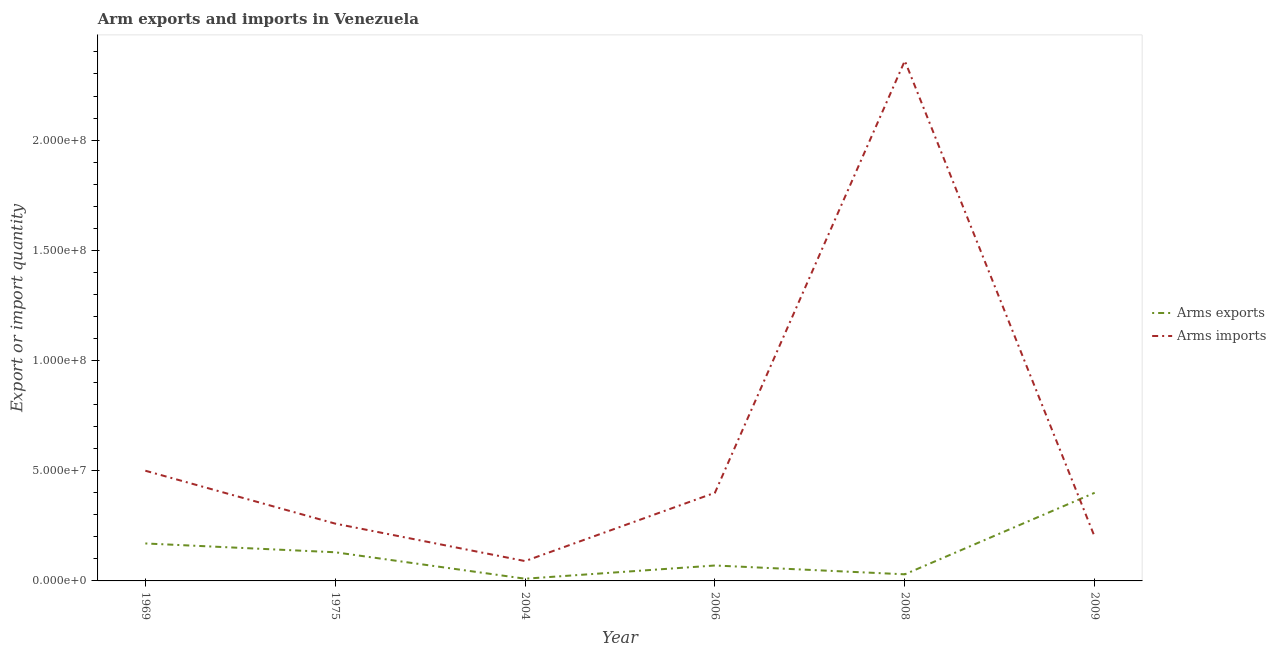Is the number of lines equal to the number of legend labels?
Your response must be concise. Yes. What is the arms imports in 2004?
Give a very brief answer. 9.00e+06. Across all years, what is the maximum arms imports?
Provide a succinct answer. 2.36e+08. Across all years, what is the minimum arms imports?
Provide a succinct answer. 9.00e+06. In which year was the arms imports minimum?
Provide a succinct answer. 2004. What is the total arms exports in the graph?
Provide a succinct answer. 8.10e+07. What is the difference between the arms exports in 1969 and that in 2006?
Provide a short and direct response. 1.00e+07. What is the difference between the arms imports in 1975 and the arms exports in 2009?
Offer a terse response. -1.40e+07. What is the average arms imports per year?
Provide a short and direct response. 6.35e+07. In the year 1969, what is the difference between the arms exports and arms imports?
Your answer should be very brief. -3.30e+07. In how many years, is the arms imports greater than 190000000?
Make the answer very short. 1. What is the ratio of the arms exports in 2004 to that in 2009?
Provide a short and direct response. 0.03. Is the difference between the arms imports in 2004 and 2009 greater than the difference between the arms exports in 2004 and 2009?
Your answer should be compact. Yes. What is the difference between the highest and the second highest arms imports?
Offer a very short reply. 1.86e+08. What is the difference between the highest and the lowest arms exports?
Your answer should be very brief. 3.90e+07. Does the arms exports monotonically increase over the years?
Your response must be concise. No. Is the arms imports strictly less than the arms exports over the years?
Keep it short and to the point. No. How many years are there in the graph?
Your response must be concise. 6. What is the difference between two consecutive major ticks on the Y-axis?
Give a very brief answer. 5.00e+07. Where does the legend appear in the graph?
Provide a succinct answer. Center right. How many legend labels are there?
Provide a short and direct response. 2. How are the legend labels stacked?
Ensure brevity in your answer.  Vertical. What is the title of the graph?
Offer a terse response. Arm exports and imports in Venezuela. Does "Primary completion rate" appear as one of the legend labels in the graph?
Your answer should be very brief. No. What is the label or title of the Y-axis?
Your response must be concise. Export or import quantity. What is the Export or import quantity in Arms exports in 1969?
Offer a terse response. 1.70e+07. What is the Export or import quantity of Arms exports in 1975?
Ensure brevity in your answer.  1.30e+07. What is the Export or import quantity in Arms imports in 1975?
Ensure brevity in your answer.  2.60e+07. What is the Export or import quantity in Arms exports in 2004?
Keep it short and to the point. 1.00e+06. What is the Export or import quantity in Arms imports in 2004?
Your answer should be very brief. 9.00e+06. What is the Export or import quantity of Arms imports in 2006?
Your answer should be very brief. 4.00e+07. What is the Export or import quantity in Arms imports in 2008?
Keep it short and to the point. 2.36e+08. What is the Export or import quantity of Arms exports in 2009?
Provide a short and direct response. 4.00e+07. What is the Export or import quantity in Arms imports in 2009?
Offer a very short reply. 2.00e+07. Across all years, what is the maximum Export or import quantity in Arms exports?
Make the answer very short. 4.00e+07. Across all years, what is the maximum Export or import quantity in Arms imports?
Your answer should be very brief. 2.36e+08. Across all years, what is the minimum Export or import quantity in Arms exports?
Provide a succinct answer. 1.00e+06. Across all years, what is the minimum Export or import quantity in Arms imports?
Ensure brevity in your answer.  9.00e+06. What is the total Export or import quantity in Arms exports in the graph?
Your answer should be very brief. 8.10e+07. What is the total Export or import quantity in Arms imports in the graph?
Offer a terse response. 3.81e+08. What is the difference between the Export or import quantity in Arms exports in 1969 and that in 1975?
Offer a very short reply. 4.00e+06. What is the difference between the Export or import quantity of Arms imports in 1969 and that in 1975?
Give a very brief answer. 2.40e+07. What is the difference between the Export or import quantity of Arms exports in 1969 and that in 2004?
Provide a succinct answer. 1.60e+07. What is the difference between the Export or import quantity of Arms imports in 1969 and that in 2004?
Ensure brevity in your answer.  4.10e+07. What is the difference between the Export or import quantity of Arms exports in 1969 and that in 2006?
Offer a very short reply. 1.00e+07. What is the difference between the Export or import quantity of Arms imports in 1969 and that in 2006?
Your answer should be compact. 1.00e+07. What is the difference between the Export or import quantity in Arms exports in 1969 and that in 2008?
Make the answer very short. 1.40e+07. What is the difference between the Export or import quantity of Arms imports in 1969 and that in 2008?
Offer a terse response. -1.86e+08. What is the difference between the Export or import quantity of Arms exports in 1969 and that in 2009?
Provide a succinct answer. -2.30e+07. What is the difference between the Export or import quantity of Arms imports in 1969 and that in 2009?
Your response must be concise. 3.00e+07. What is the difference between the Export or import quantity of Arms exports in 1975 and that in 2004?
Provide a short and direct response. 1.20e+07. What is the difference between the Export or import quantity in Arms imports in 1975 and that in 2004?
Provide a succinct answer. 1.70e+07. What is the difference between the Export or import quantity in Arms imports in 1975 and that in 2006?
Offer a terse response. -1.40e+07. What is the difference between the Export or import quantity in Arms imports in 1975 and that in 2008?
Your response must be concise. -2.10e+08. What is the difference between the Export or import quantity in Arms exports in 1975 and that in 2009?
Your answer should be compact. -2.70e+07. What is the difference between the Export or import quantity in Arms imports in 1975 and that in 2009?
Give a very brief answer. 6.00e+06. What is the difference between the Export or import quantity of Arms exports in 2004 and that in 2006?
Make the answer very short. -6.00e+06. What is the difference between the Export or import quantity of Arms imports in 2004 and that in 2006?
Your answer should be very brief. -3.10e+07. What is the difference between the Export or import quantity of Arms imports in 2004 and that in 2008?
Provide a succinct answer. -2.27e+08. What is the difference between the Export or import quantity of Arms exports in 2004 and that in 2009?
Offer a very short reply. -3.90e+07. What is the difference between the Export or import quantity of Arms imports in 2004 and that in 2009?
Offer a very short reply. -1.10e+07. What is the difference between the Export or import quantity in Arms imports in 2006 and that in 2008?
Offer a very short reply. -1.96e+08. What is the difference between the Export or import quantity in Arms exports in 2006 and that in 2009?
Ensure brevity in your answer.  -3.30e+07. What is the difference between the Export or import quantity of Arms exports in 2008 and that in 2009?
Ensure brevity in your answer.  -3.70e+07. What is the difference between the Export or import quantity of Arms imports in 2008 and that in 2009?
Offer a very short reply. 2.16e+08. What is the difference between the Export or import quantity of Arms exports in 1969 and the Export or import quantity of Arms imports in 1975?
Keep it short and to the point. -9.00e+06. What is the difference between the Export or import quantity in Arms exports in 1969 and the Export or import quantity in Arms imports in 2006?
Offer a very short reply. -2.30e+07. What is the difference between the Export or import quantity in Arms exports in 1969 and the Export or import quantity in Arms imports in 2008?
Provide a succinct answer. -2.19e+08. What is the difference between the Export or import quantity of Arms exports in 1975 and the Export or import quantity of Arms imports in 2004?
Your answer should be compact. 4.00e+06. What is the difference between the Export or import quantity in Arms exports in 1975 and the Export or import quantity in Arms imports in 2006?
Your answer should be very brief. -2.70e+07. What is the difference between the Export or import quantity in Arms exports in 1975 and the Export or import quantity in Arms imports in 2008?
Offer a terse response. -2.23e+08. What is the difference between the Export or import quantity of Arms exports in 1975 and the Export or import quantity of Arms imports in 2009?
Provide a short and direct response. -7.00e+06. What is the difference between the Export or import quantity of Arms exports in 2004 and the Export or import quantity of Arms imports in 2006?
Give a very brief answer. -3.90e+07. What is the difference between the Export or import quantity in Arms exports in 2004 and the Export or import quantity in Arms imports in 2008?
Offer a terse response. -2.35e+08. What is the difference between the Export or import quantity in Arms exports in 2004 and the Export or import quantity in Arms imports in 2009?
Offer a very short reply. -1.90e+07. What is the difference between the Export or import quantity in Arms exports in 2006 and the Export or import quantity in Arms imports in 2008?
Offer a very short reply. -2.29e+08. What is the difference between the Export or import quantity of Arms exports in 2006 and the Export or import quantity of Arms imports in 2009?
Provide a succinct answer. -1.30e+07. What is the difference between the Export or import quantity of Arms exports in 2008 and the Export or import quantity of Arms imports in 2009?
Ensure brevity in your answer.  -1.70e+07. What is the average Export or import quantity of Arms exports per year?
Make the answer very short. 1.35e+07. What is the average Export or import quantity in Arms imports per year?
Keep it short and to the point. 6.35e+07. In the year 1969, what is the difference between the Export or import quantity of Arms exports and Export or import quantity of Arms imports?
Offer a very short reply. -3.30e+07. In the year 1975, what is the difference between the Export or import quantity of Arms exports and Export or import quantity of Arms imports?
Keep it short and to the point. -1.30e+07. In the year 2004, what is the difference between the Export or import quantity in Arms exports and Export or import quantity in Arms imports?
Keep it short and to the point. -8.00e+06. In the year 2006, what is the difference between the Export or import quantity in Arms exports and Export or import quantity in Arms imports?
Keep it short and to the point. -3.30e+07. In the year 2008, what is the difference between the Export or import quantity in Arms exports and Export or import quantity in Arms imports?
Your answer should be very brief. -2.33e+08. What is the ratio of the Export or import quantity in Arms exports in 1969 to that in 1975?
Provide a succinct answer. 1.31. What is the ratio of the Export or import quantity of Arms imports in 1969 to that in 1975?
Offer a terse response. 1.92. What is the ratio of the Export or import quantity of Arms exports in 1969 to that in 2004?
Your answer should be compact. 17. What is the ratio of the Export or import quantity in Arms imports in 1969 to that in 2004?
Your answer should be very brief. 5.56. What is the ratio of the Export or import quantity of Arms exports in 1969 to that in 2006?
Provide a short and direct response. 2.43. What is the ratio of the Export or import quantity in Arms exports in 1969 to that in 2008?
Your answer should be very brief. 5.67. What is the ratio of the Export or import quantity in Arms imports in 1969 to that in 2008?
Keep it short and to the point. 0.21. What is the ratio of the Export or import quantity in Arms exports in 1969 to that in 2009?
Your answer should be very brief. 0.42. What is the ratio of the Export or import quantity of Arms imports in 1969 to that in 2009?
Provide a succinct answer. 2.5. What is the ratio of the Export or import quantity in Arms imports in 1975 to that in 2004?
Offer a very short reply. 2.89. What is the ratio of the Export or import quantity of Arms exports in 1975 to that in 2006?
Provide a short and direct response. 1.86. What is the ratio of the Export or import quantity in Arms imports in 1975 to that in 2006?
Make the answer very short. 0.65. What is the ratio of the Export or import quantity in Arms exports in 1975 to that in 2008?
Your answer should be compact. 4.33. What is the ratio of the Export or import quantity of Arms imports in 1975 to that in 2008?
Give a very brief answer. 0.11. What is the ratio of the Export or import quantity of Arms exports in 1975 to that in 2009?
Your answer should be very brief. 0.33. What is the ratio of the Export or import quantity in Arms exports in 2004 to that in 2006?
Offer a terse response. 0.14. What is the ratio of the Export or import quantity in Arms imports in 2004 to that in 2006?
Offer a terse response. 0.23. What is the ratio of the Export or import quantity in Arms imports in 2004 to that in 2008?
Make the answer very short. 0.04. What is the ratio of the Export or import quantity in Arms exports in 2004 to that in 2009?
Keep it short and to the point. 0.03. What is the ratio of the Export or import quantity in Arms imports in 2004 to that in 2009?
Make the answer very short. 0.45. What is the ratio of the Export or import quantity in Arms exports in 2006 to that in 2008?
Keep it short and to the point. 2.33. What is the ratio of the Export or import quantity in Arms imports in 2006 to that in 2008?
Ensure brevity in your answer.  0.17. What is the ratio of the Export or import quantity in Arms exports in 2006 to that in 2009?
Your response must be concise. 0.17. What is the ratio of the Export or import quantity in Arms imports in 2006 to that in 2009?
Ensure brevity in your answer.  2. What is the ratio of the Export or import quantity of Arms exports in 2008 to that in 2009?
Provide a succinct answer. 0.07. What is the difference between the highest and the second highest Export or import quantity of Arms exports?
Give a very brief answer. 2.30e+07. What is the difference between the highest and the second highest Export or import quantity in Arms imports?
Keep it short and to the point. 1.86e+08. What is the difference between the highest and the lowest Export or import quantity in Arms exports?
Make the answer very short. 3.90e+07. What is the difference between the highest and the lowest Export or import quantity in Arms imports?
Ensure brevity in your answer.  2.27e+08. 